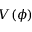Convert formula to latex. <formula><loc_0><loc_0><loc_500><loc_500>V ( \phi )</formula> 